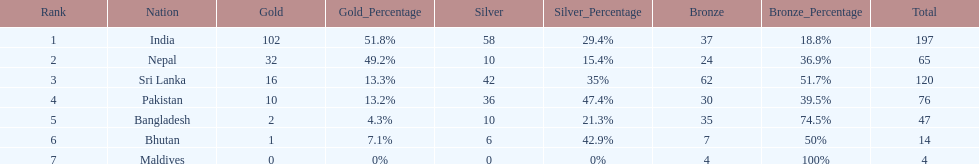What is the difference in total number of medals between india and nepal? 132. 